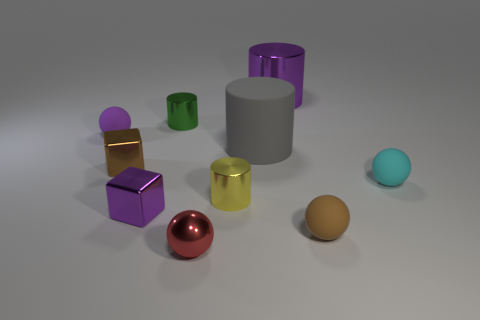Is the size of the cyan matte thing the same as the purple metallic object that is in front of the large purple shiny cylinder?
Your answer should be compact. Yes. What number of cylinders are large shiny objects or small metallic things?
Provide a short and direct response. 3. What number of purple objects are in front of the yellow cylinder and to the right of the green cylinder?
Offer a terse response. 0. How many other things are there of the same color as the big shiny thing?
Your answer should be very brief. 2. What shape is the brown object that is right of the green cylinder?
Make the answer very short. Sphere. Are the tiny red thing and the tiny cyan object made of the same material?
Your answer should be very brief. No. Are there any other things that are the same size as the brown block?
Keep it short and to the point. Yes. How many large purple cylinders are behind the small red shiny object?
Give a very brief answer. 1. There is a tiny matte object behind the metal object to the left of the small purple metal thing; what is its shape?
Ensure brevity in your answer.  Sphere. Is there any other thing that is the same shape as the gray rubber thing?
Your answer should be compact. Yes. 